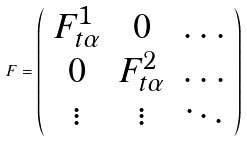Convert formula to latex. <formula><loc_0><loc_0><loc_500><loc_500>F = \left ( \begin{array} { c c c } F ^ { 1 } _ { t \alpha } & 0 & \dots \\ 0 & F ^ { 2 } _ { t \alpha } & \dots \\ \vdots & \vdots & \ddots \end{array} \right )</formula> 